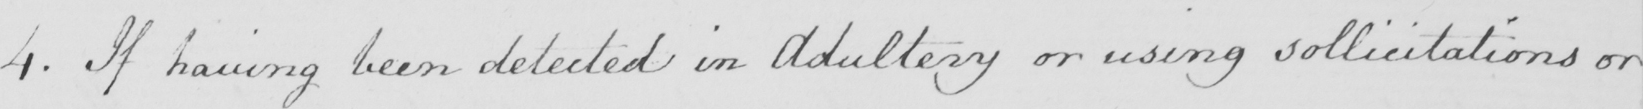What text is written in this handwritten line? 4 . If having been detected in Adultery or using sollicitations or 